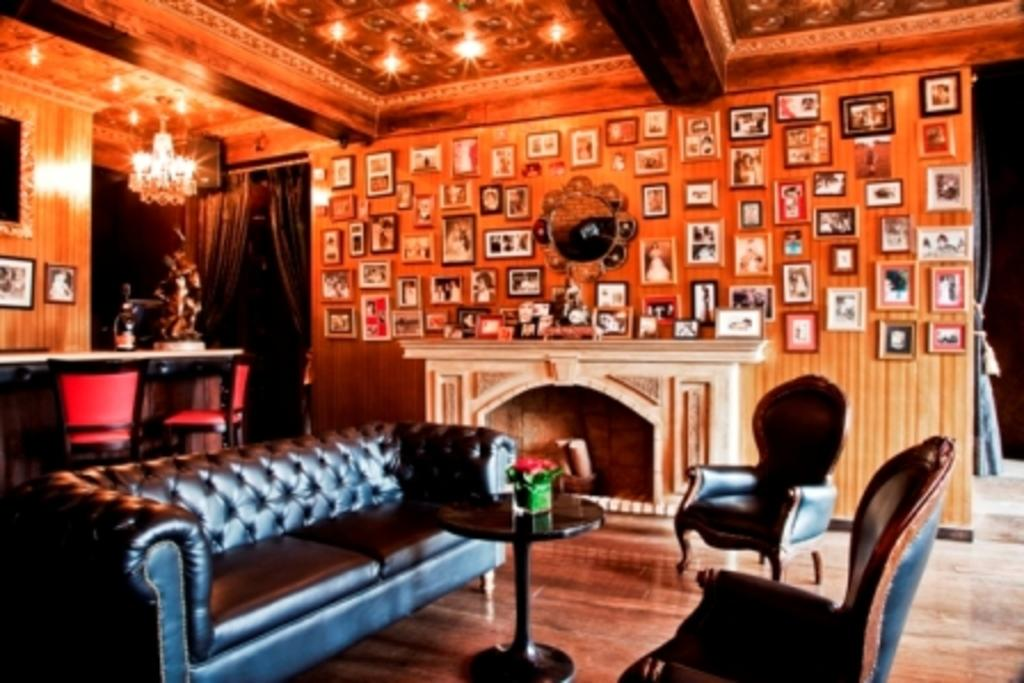What type of space is shown in the image? The image depicts the interior of a room. What type of furniture can be seen in the room? There are chairs and a sofa set in the room. What is the primary piece of furniture in the room? The primary piece of furniture in the room is a table. What decorative items are present on the wall? There are photo frames on the wall. What type of lighting is present in the room? There is a chandelier light in the room. What type of cork can be seen on the table in the image? There is no cork present on the table in the image. What type of tin is used to create the photo frames on the wall? The photo frames on the wall are not made of tin; they are made of a different material. 